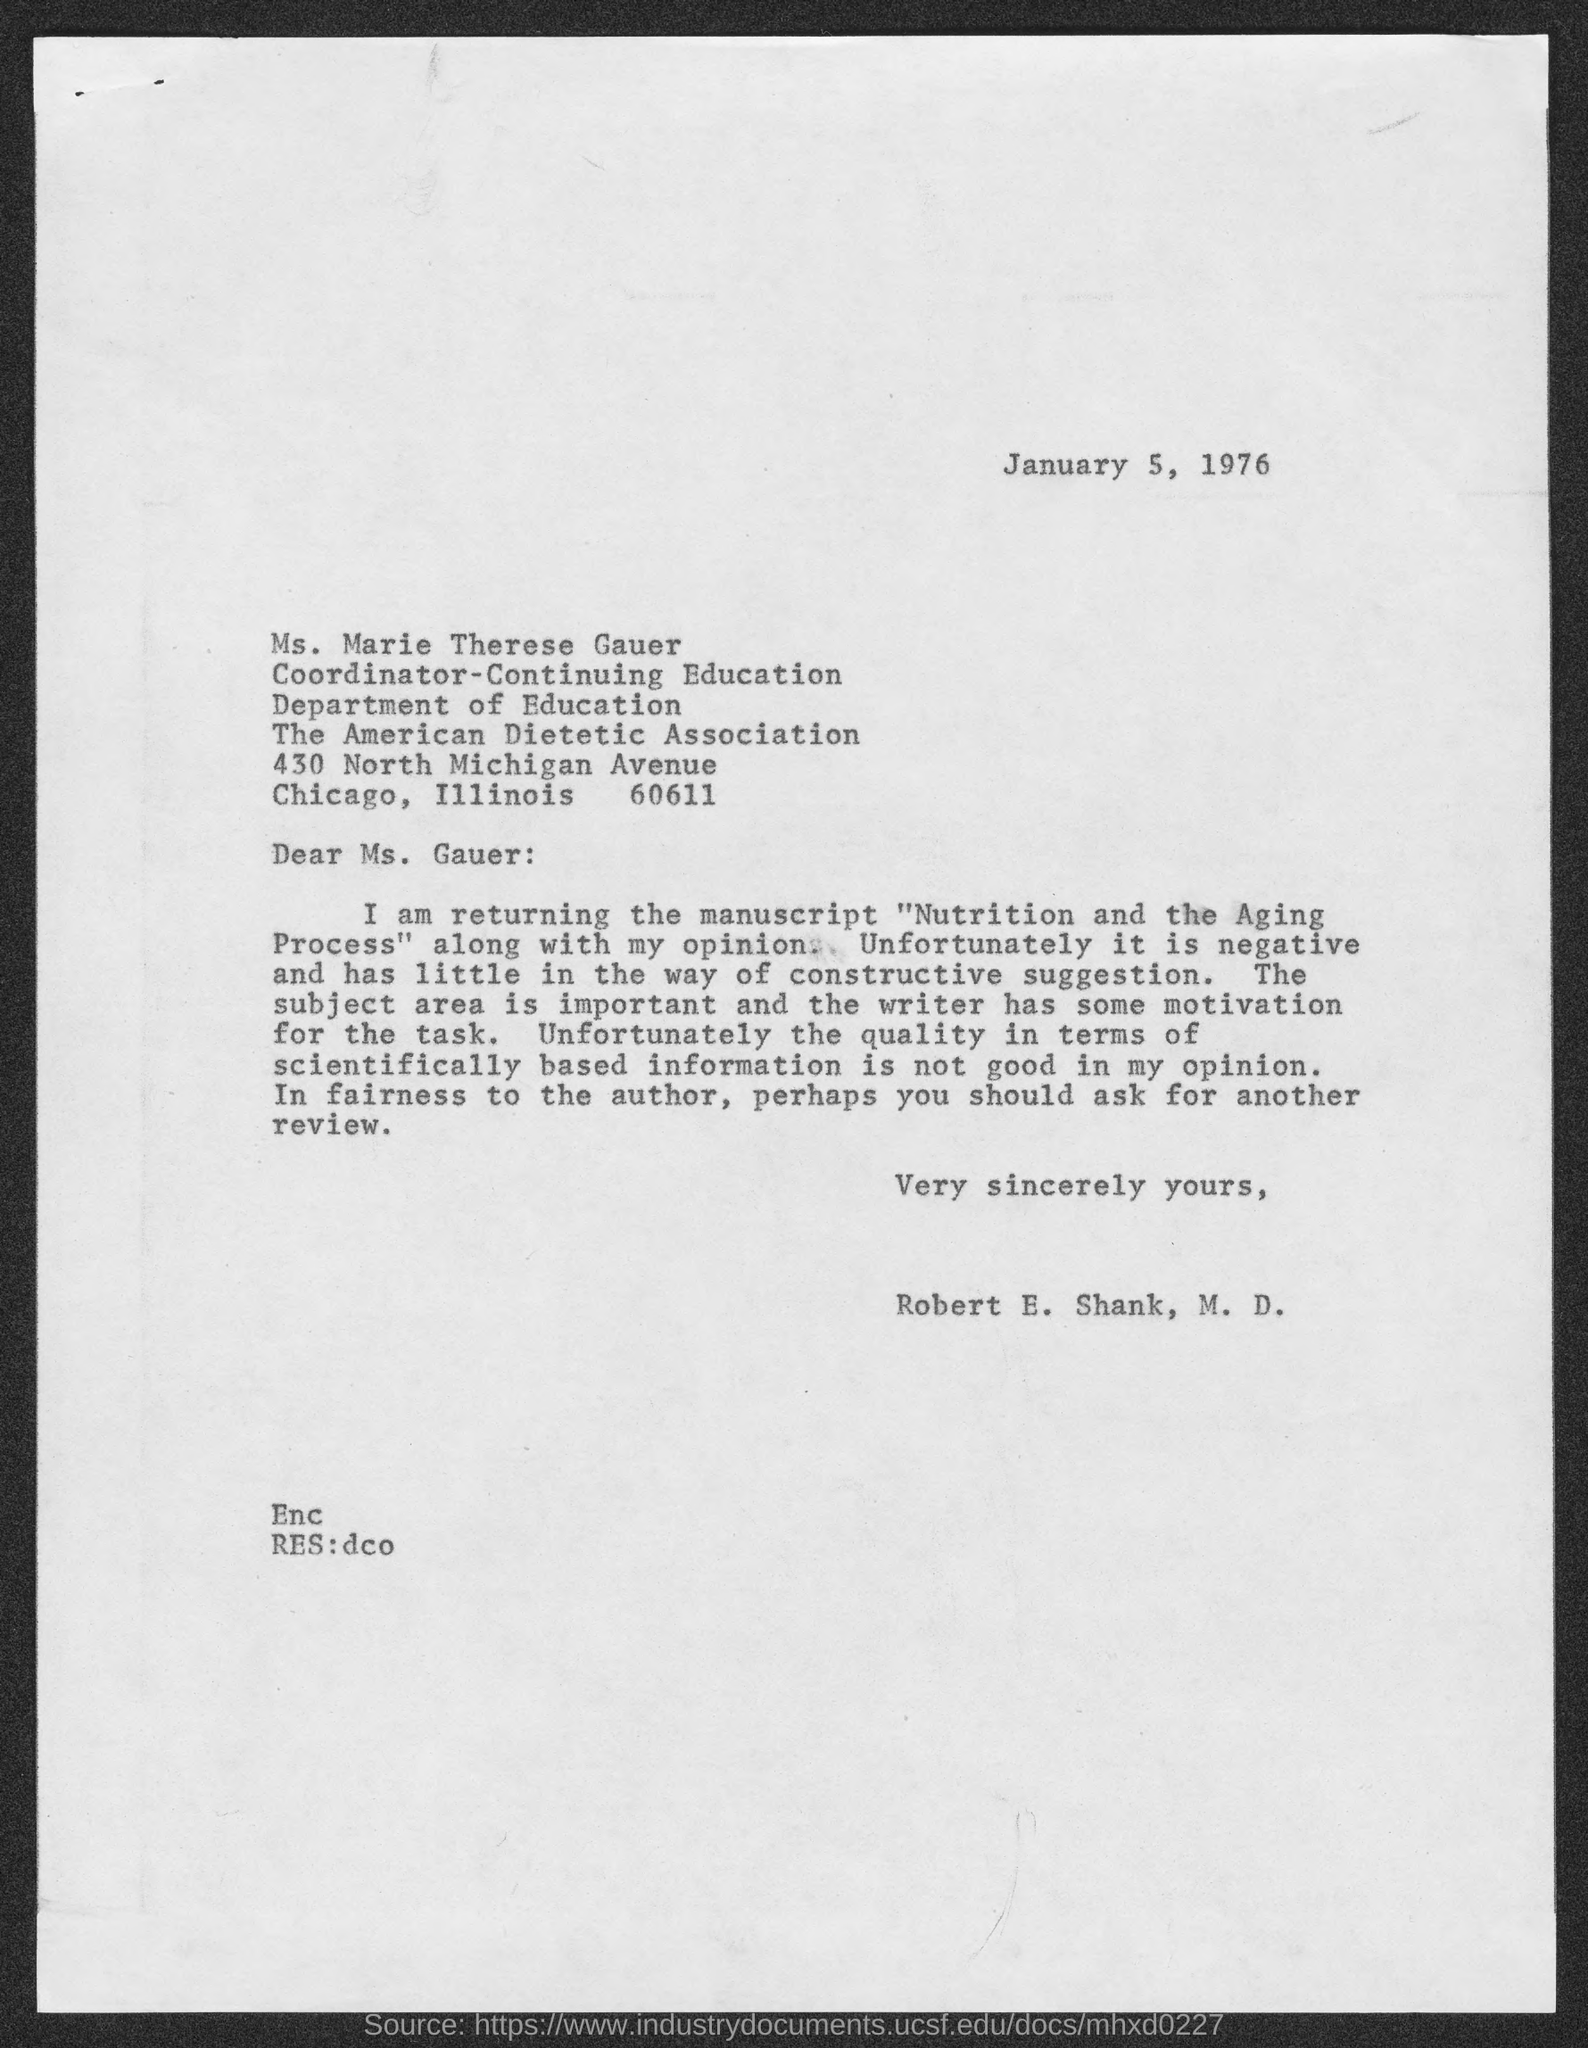When is the Memorandum dated on ?
Provide a succinct answer. January 5, 1976. Who is the Memorandum addressed to ?
Provide a short and direct response. Ms. Gauer. 